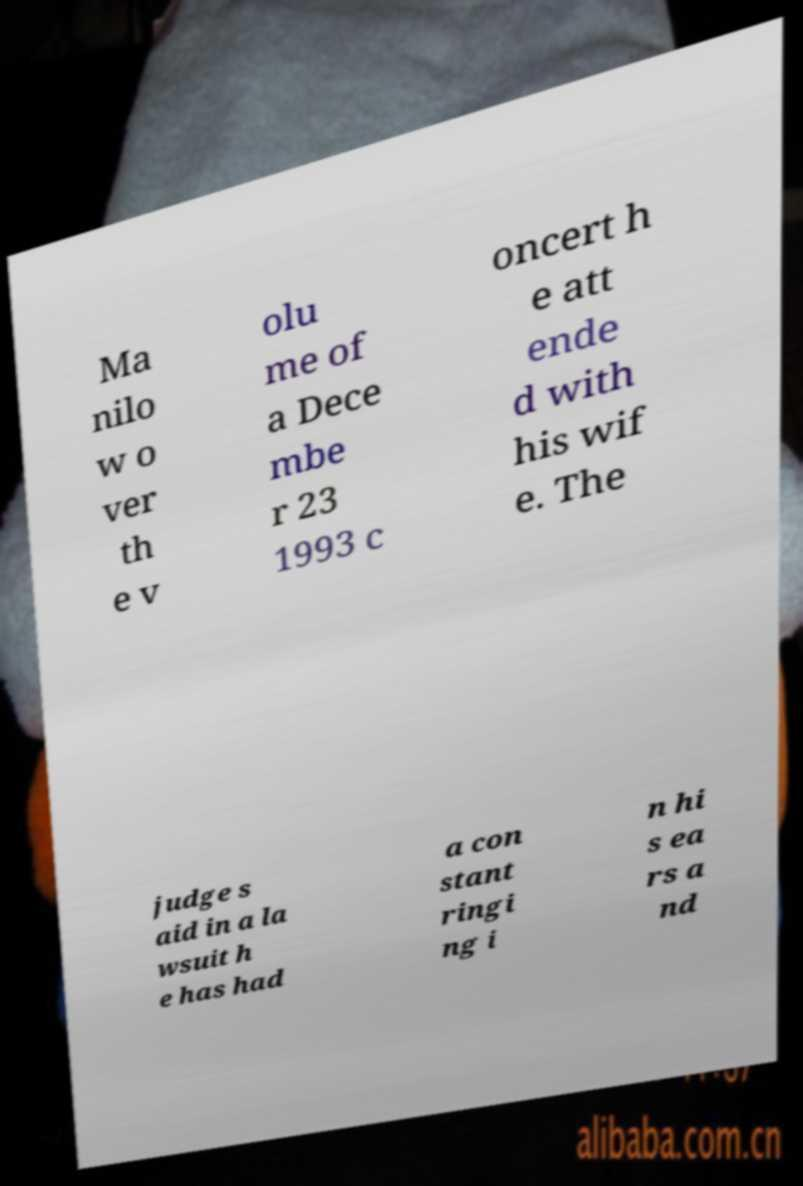Could you assist in decoding the text presented in this image and type it out clearly? Ma nilo w o ver th e v olu me of a Dece mbe r 23 1993 c oncert h e att ende d with his wif e. The judge s aid in a la wsuit h e has had a con stant ringi ng i n hi s ea rs a nd 